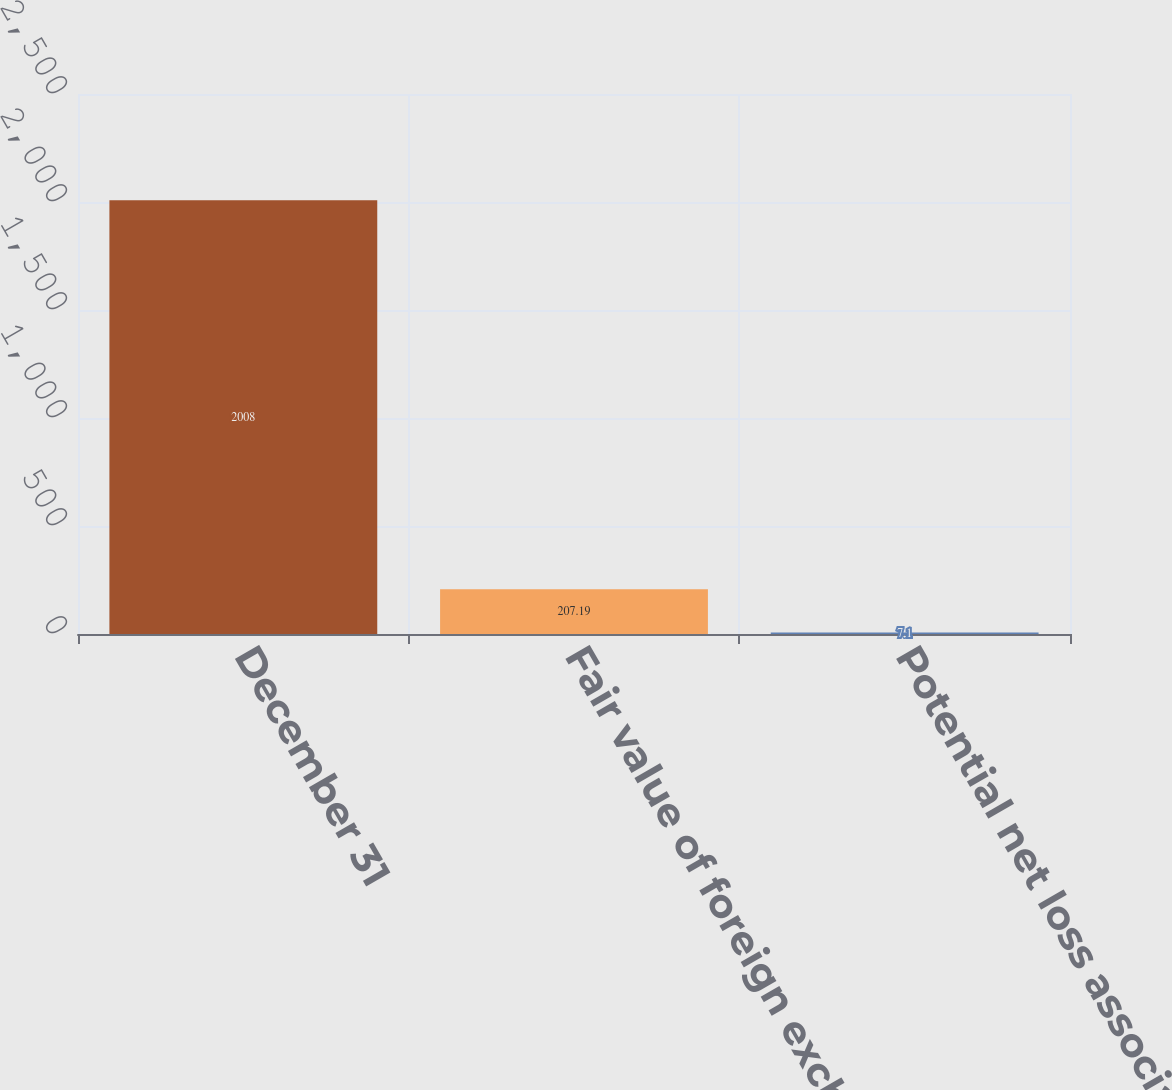Convert chart. <chart><loc_0><loc_0><loc_500><loc_500><bar_chart><fcel>December 31<fcel>Fair value of foreign exchange<fcel>Potential net loss associated<nl><fcel>2008<fcel>207.19<fcel>7.1<nl></chart> 